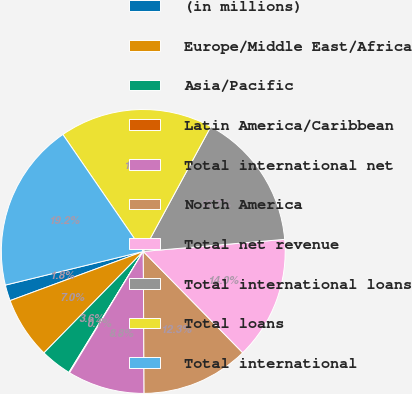<chart> <loc_0><loc_0><loc_500><loc_500><pie_chart><fcel>(in millions)<fcel>Europe/Middle East/Africa<fcel>Asia/Pacific<fcel>Latin America/Caribbean<fcel>Total international net<fcel>North America<fcel>Total net revenue<fcel>Total international loans<fcel>Total loans<fcel>Total international<nl><fcel>1.82%<fcel>7.04%<fcel>3.56%<fcel>0.08%<fcel>8.78%<fcel>12.26%<fcel>14.0%<fcel>15.74%<fcel>17.48%<fcel>19.22%<nl></chart> 